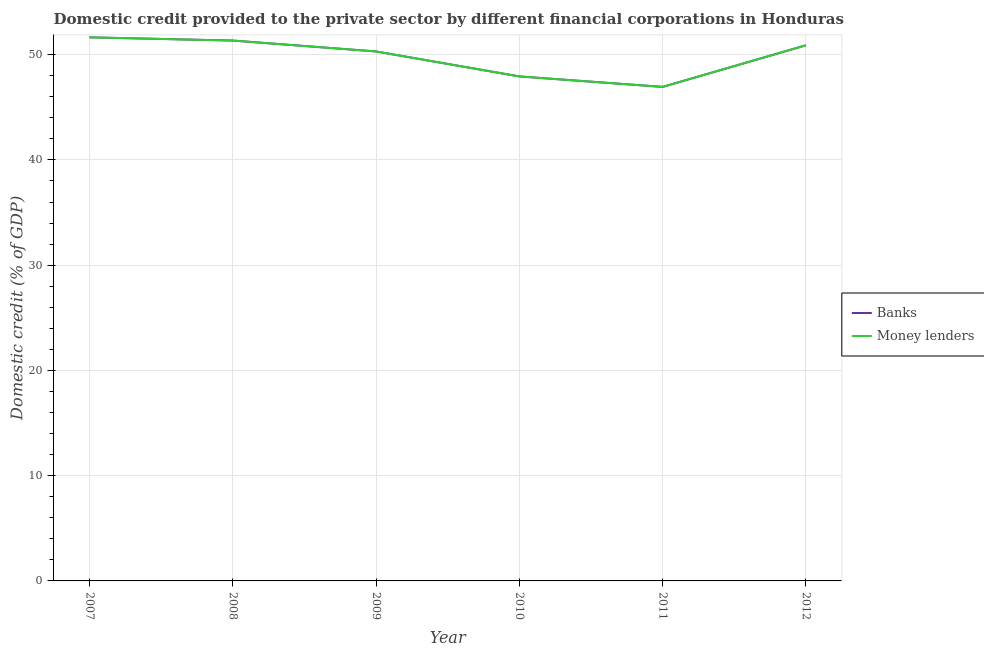How many different coloured lines are there?
Give a very brief answer. 2. What is the domestic credit provided by money lenders in 2007?
Keep it short and to the point. 51.65. Across all years, what is the maximum domestic credit provided by money lenders?
Your response must be concise. 51.65. Across all years, what is the minimum domestic credit provided by banks?
Provide a short and direct response. 46.94. In which year was the domestic credit provided by money lenders maximum?
Give a very brief answer. 2007. In which year was the domestic credit provided by banks minimum?
Make the answer very short. 2011. What is the total domestic credit provided by money lenders in the graph?
Offer a very short reply. 299.07. What is the difference between the domestic credit provided by money lenders in 2008 and that in 2010?
Your answer should be compact. 3.41. What is the difference between the domestic credit provided by banks in 2011 and the domestic credit provided by money lenders in 2012?
Make the answer very short. -3.96. What is the average domestic credit provided by money lenders per year?
Your answer should be compact. 49.84. In how many years, is the domestic credit provided by banks greater than 36 %?
Make the answer very short. 6. What is the ratio of the domestic credit provided by banks in 2007 to that in 2012?
Keep it short and to the point. 1.01. Is the domestic credit provided by banks in 2008 less than that in 2009?
Make the answer very short. No. Is the difference between the domestic credit provided by money lenders in 2011 and 2012 greater than the difference between the domestic credit provided by banks in 2011 and 2012?
Ensure brevity in your answer.  No. What is the difference between the highest and the second highest domestic credit provided by banks?
Your answer should be very brief. 0.3. What is the difference between the highest and the lowest domestic credit provided by money lenders?
Your answer should be compact. 4.71. Is the sum of the domestic credit provided by banks in 2009 and 2010 greater than the maximum domestic credit provided by money lenders across all years?
Your answer should be very brief. Yes. Is the domestic credit provided by money lenders strictly greater than the domestic credit provided by banks over the years?
Offer a very short reply. No. Is the domestic credit provided by money lenders strictly less than the domestic credit provided by banks over the years?
Offer a terse response. No. How many lines are there?
Your answer should be very brief. 2. Where does the legend appear in the graph?
Make the answer very short. Center right. How many legend labels are there?
Keep it short and to the point. 2. What is the title of the graph?
Provide a short and direct response. Domestic credit provided to the private sector by different financial corporations in Honduras. Does "All education staff compensation" appear as one of the legend labels in the graph?
Offer a very short reply. No. What is the label or title of the Y-axis?
Ensure brevity in your answer.  Domestic credit (% of GDP). What is the Domestic credit (% of GDP) of Banks in 2007?
Keep it short and to the point. 51.65. What is the Domestic credit (% of GDP) of Money lenders in 2007?
Provide a short and direct response. 51.65. What is the Domestic credit (% of GDP) in Banks in 2008?
Offer a terse response. 51.34. What is the Domestic credit (% of GDP) of Money lenders in 2008?
Keep it short and to the point. 51.34. What is the Domestic credit (% of GDP) in Banks in 2009?
Provide a succinct answer. 50.31. What is the Domestic credit (% of GDP) in Money lenders in 2009?
Your response must be concise. 50.31. What is the Domestic credit (% of GDP) in Banks in 2010?
Provide a short and direct response. 47.93. What is the Domestic credit (% of GDP) of Money lenders in 2010?
Your answer should be very brief. 47.93. What is the Domestic credit (% of GDP) of Banks in 2011?
Provide a short and direct response. 46.94. What is the Domestic credit (% of GDP) of Money lenders in 2011?
Keep it short and to the point. 46.94. What is the Domestic credit (% of GDP) of Banks in 2012?
Ensure brevity in your answer.  50.9. What is the Domestic credit (% of GDP) in Money lenders in 2012?
Your response must be concise. 50.9. Across all years, what is the maximum Domestic credit (% of GDP) of Banks?
Make the answer very short. 51.65. Across all years, what is the maximum Domestic credit (% of GDP) of Money lenders?
Make the answer very short. 51.65. Across all years, what is the minimum Domestic credit (% of GDP) in Banks?
Your answer should be compact. 46.94. Across all years, what is the minimum Domestic credit (% of GDP) in Money lenders?
Ensure brevity in your answer.  46.94. What is the total Domestic credit (% of GDP) in Banks in the graph?
Give a very brief answer. 299.07. What is the total Domestic credit (% of GDP) of Money lenders in the graph?
Offer a very short reply. 299.07. What is the difference between the Domestic credit (% of GDP) in Banks in 2007 and that in 2008?
Offer a very short reply. 0.3. What is the difference between the Domestic credit (% of GDP) of Money lenders in 2007 and that in 2008?
Keep it short and to the point. 0.3. What is the difference between the Domestic credit (% of GDP) of Banks in 2007 and that in 2009?
Provide a succinct answer. 1.34. What is the difference between the Domestic credit (% of GDP) in Money lenders in 2007 and that in 2009?
Provide a succinct answer. 1.34. What is the difference between the Domestic credit (% of GDP) of Banks in 2007 and that in 2010?
Provide a succinct answer. 3.71. What is the difference between the Domestic credit (% of GDP) in Money lenders in 2007 and that in 2010?
Provide a short and direct response. 3.71. What is the difference between the Domestic credit (% of GDP) of Banks in 2007 and that in 2011?
Offer a very short reply. 4.71. What is the difference between the Domestic credit (% of GDP) in Money lenders in 2007 and that in 2011?
Provide a short and direct response. 4.71. What is the difference between the Domestic credit (% of GDP) of Banks in 2007 and that in 2012?
Keep it short and to the point. 0.75. What is the difference between the Domestic credit (% of GDP) of Money lenders in 2007 and that in 2012?
Offer a terse response. 0.75. What is the difference between the Domestic credit (% of GDP) in Banks in 2008 and that in 2009?
Provide a succinct answer. 1.04. What is the difference between the Domestic credit (% of GDP) of Money lenders in 2008 and that in 2009?
Keep it short and to the point. 1.04. What is the difference between the Domestic credit (% of GDP) of Banks in 2008 and that in 2010?
Ensure brevity in your answer.  3.41. What is the difference between the Domestic credit (% of GDP) in Money lenders in 2008 and that in 2010?
Your answer should be very brief. 3.41. What is the difference between the Domestic credit (% of GDP) of Banks in 2008 and that in 2011?
Keep it short and to the point. 4.4. What is the difference between the Domestic credit (% of GDP) in Money lenders in 2008 and that in 2011?
Provide a short and direct response. 4.4. What is the difference between the Domestic credit (% of GDP) in Banks in 2008 and that in 2012?
Offer a terse response. 0.45. What is the difference between the Domestic credit (% of GDP) of Money lenders in 2008 and that in 2012?
Ensure brevity in your answer.  0.45. What is the difference between the Domestic credit (% of GDP) in Banks in 2009 and that in 2010?
Offer a terse response. 2.37. What is the difference between the Domestic credit (% of GDP) of Money lenders in 2009 and that in 2010?
Your response must be concise. 2.37. What is the difference between the Domestic credit (% of GDP) in Banks in 2009 and that in 2011?
Offer a terse response. 3.37. What is the difference between the Domestic credit (% of GDP) in Money lenders in 2009 and that in 2011?
Your answer should be very brief. 3.37. What is the difference between the Domestic credit (% of GDP) of Banks in 2009 and that in 2012?
Provide a short and direct response. -0.59. What is the difference between the Domestic credit (% of GDP) of Money lenders in 2009 and that in 2012?
Offer a terse response. -0.59. What is the difference between the Domestic credit (% of GDP) of Banks in 2010 and that in 2011?
Make the answer very short. 0.99. What is the difference between the Domestic credit (% of GDP) of Money lenders in 2010 and that in 2011?
Your answer should be compact. 0.99. What is the difference between the Domestic credit (% of GDP) in Banks in 2010 and that in 2012?
Your response must be concise. -2.96. What is the difference between the Domestic credit (% of GDP) of Money lenders in 2010 and that in 2012?
Ensure brevity in your answer.  -2.96. What is the difference between the Domestic credit (% of GDP) of Banks in 2011 and that in 2012?
Make the answer very short. -3.96. What is the difference between the Domestic credit (% of GDP) of Money lenders in 2011 and that in 2012?
Make the answer very short. -3.96. What is the difference between the Domestic credit (% of GDP) of Banks in 2007 and the Domestic credit (% of GDP) of Money lenders in 2008?
Your answer should be very brief. 0.3. What is the difference between the Domestic credit (% of GDP) in Banks in 2007 and the Domestic credit (% of GDP) in Money lenders in 2009?
Give a very brief answer. 1.34. What is the difference between the Domestic credit (% of GDP) of Banks in 2007 and the Domestic credit (% of GDP) of Money lenders in 2010?
Provide a short and direct response. 3.71. What is the difference between the Domestic credit (% of GDP) in Banks in 2007 and the Domestic credit (% of GDP) in Money lenders in 2011?
Make the answer very short. 4.71. What is the difference between the Domestic credit (% of GDP) of Banks in 2007 and the Domestic credit (% of GDP) of Money lenders in 2012?
Keep it short and to the point. 0.75. What is the difference between the Domestic credit (% of GDP) in Banks in 2008 and the Domestic credit (% of GDP) in Money lenders in 2009?
Offer a terse response. 1.04. What is the difference between the Domestic credit (% of GDP) in Banks in 2008 and the Domestic credit (% of GDP) in Money lenders in 2010?
Offer a terse response. 3.41. What is the difference between the Domestic credit (% of GDP) of Banks in 2008 and the Domestic credit (% of GDP) of Money lenders in 2011?
Your answer should be compact. 4.4. What is the difference between the Domestic credit (% of GDP) in Banks in 2008 and the Domestic credit (% of GDP) in Money lenders in 2012?
Give a very brief answer. 0.45. What is the difference between the Domestic credit (% of GDP) of Banks in 2009 and the Domestic credit (% of GDP) of Money lenders in 2010?
Your response must be concise. 2.37. What is the difference between the Domestic credit (% of GDP) in Banks in 2009 and the Domestic credit (% of GDP) in Money lenders in 2011?
Offer a terse response. 3.37. What is the difference between the Domestic credit (% of GDP) of Banks in 2009 and the Domestic credit (% of GDP) of Money lenders in 2012?
Give a very brief answer. -0.59. What is the difference between the Domestic credit (% of GDP) in Banks in 2010 and the Domestic credit (% of GDP) in Money lenders in 2011?
Offer a terse response. 0.99. What is the difference between the Domestic credit (% of GDP) of Banks in 2010 and the Domestic credit (% of GDP) of Money lenders in 2012?
Give a very brief answer. -2.96. What is the difference between the Domestic credit (% of GDP) in Banks in 2011 and the Domestic credit (% of GDP) in Money lenders in 2012?
Provide a succinct answer. -3.96. What is the average Domestic credit (% of GDP) of Banks per year?
Ensure brevity in your answer.  49.84. What is the average Domestic credit (% of GDP) of Money lenders per year?
Offer a terse response. 49.84. In the year 2009, what is the difference between the Domestic credit (% of GDP) in Banks and Domestic credit (% of GDP) in Money lenders?
Ensure brevity in your answer.  0. In the year 2010, what is the difference between the Domestic credit (% of GDP) of Banks and Domestic credit (% of GDP) of Money lenders?
Give a very brief answer. 0. What is the ratio of the Domestic credit (% of GDP) of Banks in 2007 to that in 2008?
Keep it short and to the point. 1.01. What is the ratio of the Domestic credit (% of GDP) in Money lenders in 2007 to that in 2008?
Keep it short and to the point. 1.01. What is the ratio of the Domestic credit (% of GDP) in Banks in 2007 to that in 2009?
Your answer should be very brief. 1.03. What is the ratio of the Domestic credit (% of GDP) in Money lenders in 2007 to that in 2009?
Give a very brief answer. 1.03. What is the ratio of the Domestic credit (% of GDP) of Banks in 2007 to that in 2010?
Offer a terse response. 1.08. What is the ratio of the Domestic credit (% of GDP) in Money lenders in 2007 to that in 2010?
Keep it short and to the point. 1.08. What is the ratio of the Domestic credit (% of GDP) in Banks in 2007 to that in 2011?
Give a very brief answer. 1.1. What is the ratio of the Domestic credit (% of GDP) of Money lenders in 2007 to that in 2011?
Your response must be concise. 1.1. What is the ratio of the Domestic credit (% of GDP) in Banks in 2007 to that in 2012?
Offer a very short reply. 1.01. What is the ratio of the Domestic credit (% of GDP) in Money lenders in 2007 to that in 2012?
Give a very brief answer. 1.01. What is the ratio of the Domestic credit (% of GDP) of Banks in 2008 to that in 2009?
Your response must be concise. 1.02. What is the ratio of the Domestic credit (% of GDP) of Money lenders in 2008 to that in 2009?
Keep it short and to the point. 1.02. What is the ratio of the Domestic credit (% of GDP) in Banks in 2008 to that in 2010?
Provide a short and direct response. 1.07. What is the ratio of the Domestic credit (% of GDP) in Money lenders in 2008 to that in 2010?
Keep it short and to the point. 1.07. What is the ratio of the Domestic credit (% of GDP) in Banks in 2008 to that in 2011?
Ensure brevity in your answer.  1.09. What is the ratio of the Domestic credit (% of GDP) in Money lenders in 2008 to that in 2011?
Ensure brevity in your answer.  1.09. What is the ratio of the Domestic credit (% of GDP) in Banks in 2008 to that in 2012?
Provide a short and direct response. 1.01. What is the ratio of the Domestic credit (% of GDP) of Money lenders in 2008 to that in 2012?
Offer a very short reply. 1.01. What is the ratio of the Domestic credit (% of GDP) of Banks in 2009 to that in 2010?
Provide a succinct answer. 1.05. What is the ratio of the Domestic credit (% of GDP) in Money lenders in 2009 to that in 2010?
Ensure brevity in your answer.  1.05. What is the ratio of the Domestic credit (% of GDP) of Banks in 2009 to that in 2011?
Your answer should be very brief. 1.07. What is the ratio of the Domestic credit (% of GDP) of Money lenders in 2009 to that in 2011?
Keep it short and to the point. 1.07. What is the ratio of the Domestic credit (% of GDP) of Banks in 2009 to that in 2012?
Offer a terse response. 0.99. What is the ratio of the Domestic credit (% of GDP) of Money lenders in 2009 to that in 2012?
Make the answer very short. 0.99. What is the ratio of the Domestic credit (% of GDP) of Banks in 2010 to that in 2011?
Make the answer very short. 1.02. What is the ratio of the Domestic credit (% of GDP) of Money lenders in 2010 to that in 2011?
Offer a terse response. 1.02. What is the ratio of the Domestic credit (% of GDP) of Banks in 2010 to that in 2012?
Provide a succinct answer. 0.94. What is the ratio of the Domestic credit (% of GDP) in Money lenders in 2010 to that in 2012?
Make the answer very short. 0.94. What is the ratio of the Domestic credit (% of GDP) of Banks in 2011 to that in 2012?
Provide a succinct answer. 0.92. What is the ratio of the Domestic credit (% of GDP) of Money lenders in 2011 to that in 2012?
Your response must be concise. 0.92. What is the difference between the highest and the second highest Domestic credit (% of GDP) in Banks?
Ensure brevity in your answer.  0.3. What is the difference between the highest and the second highest Domestic credit (% of GDP) of Money lenders?
Provide a short and direct response. 0.3. What is the difference between the highest and the lowest Domestic credit (% of GDP) of Banks?
Make the answer very short. 4.71. What is the difference between the highest and the lowest Domestic credit (% of GDP) in Money lenders?
Your answer should be compact. 4.71. 